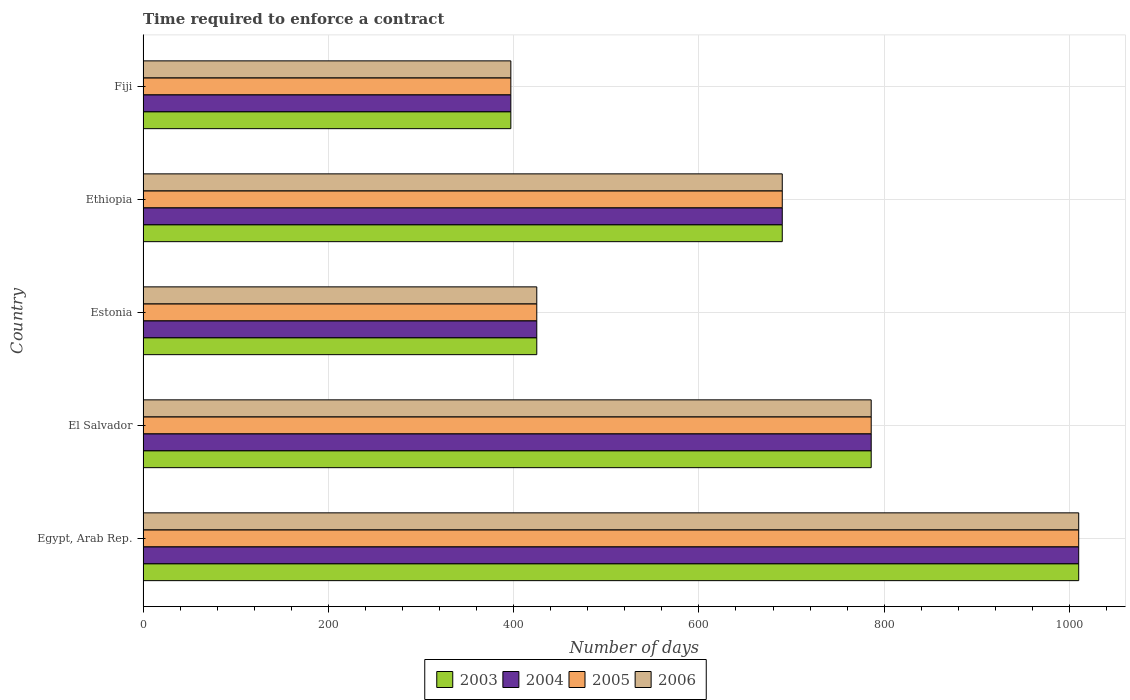How many groups of bars are there?
Provide a short and direct response. 5. Are the number of bars per tick equal to the number of legend labels?
Give a very brief answer. Yes. How many bars are there on the 3rd tick from the bottom?
Your response must be concise. 4. What is the label of the 5th group of bars from the top?
Ensure brevity in your answer.  Egypt, Arab Rep. What is the number of days required to enforce a contract in 2003 in Ethiopia?
Your answer should be compact. 690. Across all countries, what is the maximum number of days required to enforce a contract in 2005?
Keep it short and to the point. 1010. Across all countries, what is the minimum number of days required to enforce a contract in 2005?
Offer a terse response. 397. In which country was the number of days required to enforce a contract in 2004 maximum?
Provide a short and direct response. Egypt, Arab Rep. In which country was the number of days required to enforce a contract in 2006 minimum?
Ensure brevity in your answer.  Fiji. What is the total number of days required to enforce a contract in 2004 in the graph?
Make the answer very short. 3308. What is the difference between the number of days required to enforce a contract in 2006 in Egypt, Arab Rep. and that in Estonia?
Your response must be concise. 585. What is the difference between the number of days required to enforce a contract in 2003 in El Salvador and the number of days required to enforce a contract in 2005 in Ethiopia?
Your answer should be compact. 96. What is the average number of days required to enforce a contract in 2003 per country?
Ensure brevity in your answer.  661.6. What is the ratio of the number of days required to enforce a contract in 2003 in Egypt, Arab Rep. to that in Fiji?
Offer a very short reply. 2.54. Is the number of days required to enforce a contract in 2004 in Ethiopia less than that in Fiji?
Ensure brevity in your answer.  No. Is the difference between the number of days required to enforce a contract in 2004 in Egypt, Arab Rep. and Fiji greater than the difference between the number of days required to enforce a contract in 2003 in Egypt, Arab Rep. and Fiji?
Offer a very short reply. No. What is the difference between the highest and the second highest number of days required to enforce a contract in 2003?
Keep it short and to the point. 224. What is the difference between the highest and the lowest number of days required to enforce a contract in 2006?
Offer a terse response. 613. Is it the case that in every country, the sum of the number of days required to enforce a contract in 2004 and number of days required to enforce a contract in 2006 is greater than the sum of number of days required to enforce a contract in 2005 and number of days required to enforce a contract in 2003?
Your answer should be compact. No. What does the 1st bar from the bottom in El Salvador represents?
Make the answer very short. 2003. Where does the legend appear in the graph?
Make the answer very short. Bottom center. How many legend labels are there?
Give a very brief answer. 4. What is the title of the graph?
Keep it short and to the point. Time required to enforce a contract. What is the label or title of the X-axis?
Ensure brevity in your answer.  Number of days. What is the Number of days of 2003 in Egypt, Arab Rep.?
Your response must be concise. 1010. What is the Number of days in 2004 in Egypt, Arab Rep.?
Your response must be concise. 1010. What is the Number of days in 2005 in Egypt, Arab Rep.?
Your answer should be compact. 1010. What is the Number of days in 2006 in Egypt, Arab Rep.?
Ensure brevity in your answer.  1010. What is the Number of days in 2003 in El Salvador?
Your answer should be very brief. 786. What is the Number of days in 2004 in El Salvador?
Your answer should be compact. 786. What is the Number of days in 2005 in El Salvador?
Provide a short and direct response. 786. What is the Number of days in 2006 in El Salvador?
Provide a succinct answer. 786. What is the Number of days of 2003 in Estonia?
Keep it short and to the point. 425. What is the Number of days in 2004 in Estonia?
Your answer should be very brief. 425. What is the Number of days of 2005 in Estonia?
Your answer should be compact. 425. What is the Number of days of 2006 in Estonia?
Offer a very short reply. 425. What is the Number of days in 2003 in Ethiopia?
Your answer should be very brief. 690. What is the Number of days of 2004 in Ethiopia?
Offer a very short reply. 690. What is the Number of days in 2005 in Ethiopia?
Offer a very short reply. 690. What is the Number of days of 2006 in Ethiopia?
Offer a very short reply. 690. What is the Number of days of 2003 in Fiji?
Provide a succinct answer. 397. What is the Number of days of 2004 in Fiji?
Keep it short and to the point. 397. What is the Number of days in 2005 in Fiji?
Offer a terse response. 397. What is the Number of days of 2006 in Fiji?
Your answer should be very brief. 397. Across all countries, what is the maximum Number of days in 2003?
Your response must be concise. 1010. Across all countries, what is the maximum Number of days of 2004?
Offer a terse response. 1010. Across all countries, what is the maximum Number of days of 2005?
Your answer should be very brief. 1010. Across all countries, what is the maximum Number of days in 2006?
Your answer should be compact. 1010. Across all countries, what is the minimum Number of days of 2003?
Provide a short and direct response. 397. Across all countries, what is the minimum Number of days in 2004?
Give a very brief answer. 397. Across all countries, what is the minimum Number of days of 2005?
Provide a short and direct response. 397. Across all countries, what is the minimum Number of days of 2006?
Make the answer very short. 397. What is the total Number of days in 2003 in the graph?
Make the answer very short. 3308. What is the total Number of days of 2004 in the graph?
Offer a terse response. 3308. What is the total Number of days in 2005 in the graph?
Your answer should be very brief. 3308. What is the total Number of days in 2006 in the graph?
Give a very brief answer. 3308. What is the difference between the Number of days in 2003 in Egypt, Arab Rep. and that in El Salvador?
Ensure brevity in your answer.  224. What is the difference between the Number of days of 2004 in Egypt, Arab Rep. and that in El Salvador?
Your answer should be compact. 224. What is the difference between the Number of days of 2005 in Egypt, Arab Rep. and that in El Salvador?
Offer a terse response. 224. What is the difference between the Number of days of 2006 in Egypt, Arab Rep. and that in El Salvador?
Provide a short and direct response. 224. What is the difference between the Number of days in 2003 in Egypt, Arab Rep. and that in Estonia?
Provide a short and direct response. 585. What is the difference between the Number of days in 2004 in Egypt, Arab Rep. and that in Estonia?
Your answer should be compact. 585. What is the difference between the Number of days in 2005 in Egypt, Arab Rep. and that in Estonia?
Your answer should be compact. 585. What is the difference between the Number of days of 2006 in Egypt, Arab Rep. and that in Estonia?
Offer a very short reply. 585. What is the difference between the Number of days of 2003 in Egypt, Arab Rep. and that in Ethiopia?
Offer a terse response. 320. What is the difference between the Number of days in 2004 in Egypt, Arab Rep. and that in Ethiopia?
Make the answer very short. 320. What is the difference between the Number of days of 2005 in Egypt, Arab Rep. and that in Ethiopia?
Provide a succinct answer. 320. What is the difference between the Number of days of 2006 in Egypt, Arab Rep. and that in Ethiopia?
Ensure brevity in your answer.  320. What is the difference between the Number of days in 2003 in Egypt, Arab Rep. and that in Fiji?
Your answer should be compact. 613. What is the difference between the Number of days of 2004 in Egypt, Arab Rep. and that in Fiji?
Your answer should be very brief. 613. What is the difference between the Number of days of 2005 in Egypt, Arab Rep. and that in Fiji?
Your answer should be very brief. 613. What is the difference between the Number of days of 2006 in Egypt, Arab Rep. and that in Fiji?
Your answer should be compact. 613. What is the difference between the Number of days in 2003 in El Salvador and that in Estonia?
Keep it short and to the point. 361. What is the difference between the Number of days in 2004 in El Salvador and that in Estonia?
Your answer should be very brief. 361. What is the difference between the Number of days of 2005 in El Salvador and that in Estonia?
Your answer should be compact. 361. What is the difference between the Number of days in 2006 in El Salvador and that in Estonia?
Offer a very short reply. 361. What is the difference between the Number of days in 2003 in El Salvador and that in Ethiopia?
Your answer should be very brief. 96. What is the difference between the Number of days in 2004 in El Salvador and that in Ethiopia?
Offer a very short reply. 96. What is the difference between the Number of days in 2005 in El Salvador and that in Ethiopia?
Provide a succinct answer. 96. What is the difference between the Number of days of 2006 in El Salvador and that in Ethiopia?
Your answer should be very brief. 96. What is the difference between the Number of days of 2003 in El Salvador and that in Fiji?
Make the answer very short. 389. What is the difference between the Number of days in 2004 in El Salvador and that in Fiji?
Offer a very short reply. 389. What is the difference between the Number of days of 2005 in El Salvador and that in Fiji?
Your response must be concise. 389. What is the difference between the Number of days of 2006 in El Salvador and that in Fiji?
Make the answer very short. 389. What is the difference between the Number of days of 2003 in Estonia and that in Ethiopia?
Offer a very short reply. -265. What is the difference between the Number of days of 2004 in Estonia and that in Ethiopia?
Your answer should be compact. -265. What is the difference between the Number of days of 2005 in Estonia and that in Ethiopia?
Ensure brevity in your answer.  -265. What is the difference between the Number of days in 2006 in Estonia and that in Ethiopia?
Give a very brief answer. -265. What is the difference between the Number of days of 2004 in Estonia and that in Fiji?
Make the answer very short. 28. What is the difference between the Number of days of 2003 in Ethiopia and that in Fiji?
Offer a very short reply. 293. What is the difference between the Number of days in 2004 in Ethiopia and that in Fiji?
Ensure brevity in your answer.  293. What is the difference between the Number of days of 2005 in Ethiopia and that in Fiji?
Ensure brevity in your answer.  293. What is the difference between the Number of days in 2006 in Ethiopia and that in Fiji?
Give a very brief answer. 293. What is the difference between the Number of days in 2003 in Egypt, Arab Rep. and the Number of days in 2004 in El Salvador?
Make the answer very short. 224. What is the difference between the Number of days of 2003 in Egypt, Arab Rep. and the Number of days of 2005 in El Salvador?
Offer a very short reply. 224. What is the difference between the Number of days of 2003 in Egypt, Arab Rep. and the Number of days of 2006 in El Salvador?
Give a very brief answer. 224. What is the difference between the Number of days in 2004 in Egypt, Arab Rep. and the Number of days in 2005 in El Salvador?
Your answer should be compact. 224. What is the difference between the Number of days in 2004 in Egypt, Arab Rep. and the Number of days in 2006 in El Salvador?
Provide a short and direct response. 224. What is the difference between the Number of days of 2005 in Egypt, Arab Rep. and the Number of days of 2006 in El Salvador?
Provide a short and direct response. 224. What is the difference between the Number of days of 2003 in Egypt, Arab Rep. and the Number of days of 2004 in Estonia?
Provide a succinct answer. 585. What is the difference between the Number of days of 2003 in Egypt, Arab Rep. and the Number of days of 2005 in Estonia?
Offer a terse response. 585. What is the difference between the Number of days in 2003 in Egypt, Arab Rep. and the Number of days in 2006 in Estonia?
Provide a succinct answer. 585. What is the difference between the Number of days of 2004 in Egypt, Arab Rep. and the Number of days of 2005 in Estonia?
Your response must be concise. 585. What is the difference between the Number of days of 2004 in Egypt, Arab Rep. and the Number of days of 2006 in Estonia?
Your response must be concise. 585. What is the difference between the Number of days of 2005 in Egypt, Arab Rep. and the Number of days of 2006 in Estonia?
Offer a very short reply. 585. What is the difference between the Number of days of 2003 in Egypt, Arab Rep. and the Number of days of 2004 in Ethiopia?
Make the answer very short. 320. What is the difference between the Number of days in 2003 in Egypt, Arab Rep. and the Number of days in 2005 in Ethiopia?
Offer a very short reply. 320. What is the difference between the Number of days in 2003 in Egypt, Arab Rep. and the Number of days in 2006 in Ethiopia?
Your answer should be compact. 320. What is the difference between the Number of days of 2004 in Egypt, Arab Rep. and the Number of days of 2005 in Ethiopia?
Provide a succinct answer. 320. What is the difference between the Number of days in 2004 in Egypt, Arab Rep. and the Number of days in 2006 in Ethiopia?
Make the answer very short. 320. What is the difference between the Number of days in 2005 in Egypt, Arab Rep. and the Number of days in 2006 in Ethiopia?
Ensure brevity in your answer.  320. What is the difference between the Number of days in 2003 in Egypt, Arab Rep. and the Number of days in 2004 in Fiji?
Provide a short and direct response. 613. What is the difference between the Number of days in 2003 in Egypt, Arab Rep. and the Number of days in 2005 in Fiji?
Provide a short and direct response. 613. What is the difference between the Number of days of 2003 in Egypt, Arab Rep. and the Number of days of 2006 in Fiji?
Make the answer very short. 613. What is the difference between the Number of days of 2004 in Egypt, Arab Rep. and the Number of days of 2005 in Fiji?
Offer a terse response. 613. What is the difference between the Number of days in 2004 in Egypt, Arab Rep. and the Number of days in 2006 in Fiji?
Make the answer very short. 613. What is the difference between the Number of days of 2005 in Egypt, Arab Rep. and the Number of days of 2006 in Fiji?
Offer a terse response. 613. What is the difference between the Number of days of 2003 in El Salvador and the Number of days of 2004 in Estonia?
Your answer should be compact. 361. What is the difference between the Number of days in 2003 in El Salvador and the Number of days in 2005 in Estonia?
Give a very brief answer. 361. What is the difference between the Number of days of 2003 in El Salvador and the Number of days of 2006 in Estonia?
Provide a succinct answer. 361. What is the difference between the Number of days in 2004 in El Salvador and the Number of days in 2005 in Estonia?
Provide a short and direct response. 361. What is the difference between the Number of days in 2004 in El Salvador and the Number of days in 2006 in Estonia?
Keep it short and to the point. 361. What is the difference between the Number of days in 2005 in El Salvador and the Number of days in 2006 in Estonia?
Provide a succinct answer. 361. What is the difference between the Number of days of 2003 in El Salvador and the Number of days of 2004 in Ethiopia?
Provide a short and direct response. 96. What is the difference between the Number of days in 2003 in El Salvador and the Number of days in 2005 in Ethiopia?
Give a very brief answer. 96. What is the difference between the Number of days in 2003 in El Salvador and the Number of days in 2006 in Ethiopia?
Provide a succinct answer. 96. What is the difference between the Number of days in 2004 in El Salvador and the Number of days in 2005 in Ethiopia?
Keep it short and to the point. 96. What is the difference between the Number of days of 2004 in El Salvador and the Number of days of 2006 in Ethiopia?
Give a very brief answer. 96. What is the difference between the Number of days of 2005 in El Salvador and the Number of days of 2006 in Ethiopia?
Make the answer very short. 96. What is the difference between the Number of days of 2003 in El Salvador and the Number of days of 2004 in Fiji?
Offer a very short reply. 389. What is the difference between the Number of days in 2003 in El Salvador and the Number of days in 2005 in Fiji?
Your answer should be very brief. 389. What is the difference between the Number of days of 2003 in El Salvador and the Number of days of 2006 in Fiji?
Your answer should be very brief. 389. What is the difference between the Number of days in 2004 in El Salvador and the Number of days in 2005 in Fiji?
Ensure brevity in your answer.  389. What is the difference between the Number of days of 2004 in El Salvador and the Number of days of 2006 in Fiji?
Make the answer very short. 389. What is the difference between the Number of days of 2005 in El Salvador and the Number of days of 2006 in Fiji?
Provide a short and direct response. 389. What is the difference between the Number of days in 2003 in Estonia and the Number of days in 2004 in Ethiopia?
Offer a very short reply. -265. What is the difference between the Number of days of 2003 in Estonia and the Number of days of 2005 in Ethiopia?
Your answer should be compact. -265. What is the difference between the Number of days in 2003 in Estonia and the Number of days in 2006 in Ethiopia?
Your answer should be very brief. -265. What is the difference between the Number of days in 2004 in Estonia and the Number of days in 2005 in Ethiopia?
Your response must be concise. -265. What is the difference between the Number of days of 2004 in Estonia and the Number of days of 2006 in Ethiopia?
Your answer should be very brief. -265. What is the difference between the Number of days in 2005 in Estonia and the Number of days in 2006 in Ethiopia?
Offer a very short reply. -265. What is the difference between the Number of days in 2003 in Estonia and the Number of days in 2004 in Fiji?
Your response must be concise. 28. What is the difference between the Number of days in 2004 in Estonia and the Number of days in 2006 in Fiji?
Your answer should be very brief. 28. What is the difference between the Number of days of 2005 in Estonia and the Number of days of 2006 in Fiji?
Your answer should be compact. 28. What is the difference between the Number of days in 2003 in Ethiopia and the Number of days in 2004 in Fiji?
Ensure brevity in your answer.  293. What is the difference between the Number of days in 2003 in Ethiopia and the Number of days in 2005 in Fiji?
Your answer should be very brief. 293. What is the difference between the Number of days in 2003 in Ethiopia and the Number of days in 2006 in Fiji?
Ensure brevity in your answer.  293. What is the difference between the Number of days of 2004 in Ethiopia and the Number of days of 2005 in Fiji?
Give a very brief answer. 293. What is the difference between the Number of days in 2004 in Ethiopia and the Number of days in 2006 in Fiji?
Your answer should be very brief. 293. What is the difference between the Number of days of 2005 in Ethiopia and the Number of days of 2006 in Fiji?
Offer a very short reply. 293. What is the average Number of days in 2003 per country?
Offer a very short reply. 661.6. What is the average Number of days of 2004 per country?
Keep it short and to the point. 661.6. What is the average Number of days of 2005 per country?
Provide a succinct answer. 661.6. What is the average Number of days in 2006 per country?
Keep it short and to the point. 661.6. What is the difference between the Number of days of 2003 and Number of days of 2004 in Egypt, Arab Rep.?
Provide a short and direct response. 0. What is the difference between the Number of days in 2003 and Number of days in 2005 in Egypt, Arab Rep.?
Give a very brief answer. 0. What is the difference between the Number of days of 2003 and Number of days of 2006 in Egypt, Arab Rep.?
Keep it short and to the point. 0. What is the difference between the Number of days in 2004 and Number of days in 2005 in Egypt, Arab Rep.?
Provide a short and direct response. 0. What is the difference between the Number of days of 2003 and Number of days of 2005 in El Salvador?
Offer a very short reply. 0. What is the difference between the Number of days in 2003 and Number of days in 2006 in El Salvador?
Ensure brevity in your answer.  0. What is the difference between the Number of days of 2004 and Number of days of 2005 in El Salvador?
Offer a very short reply. 0. What is the difference between the Number of days in 2005 and Number of days in 2006 in El Salvador?
Provide a succinct answer. 0. What is the difference between the Number of days in 2003 and Number of days in 2004 in Estonia?
Make the answer very short. 0. What is the difference between the Number of days of 2004 and Number of days of 2005 in Estonia?
Offer a terse response. 0. What is the difference between the Number of days of 2004 and Number of days of 2006 in Estonia?
Your answer should be very brief. 0. What is the difference between the Number of days of 2005 and Number of days of 2006 in Estonia?
Your answer should be very brief. 0. What is the difference between the Number of days of 2003 and Number of days of 2004 in Ethiopia?
Keep it short and to the point. 0. What is the difference between the Number of days of 2005 and Number of days of 2006 in Ethiopia?
Offer a terse response. 0. What is the difference between the Number of days of 2003 and Number of days of 2004 in Fiji?
Give a very brief answer. 0. What is the difference between the Number of days of 2003 and Number of days of 2005 in Fiji?
Provide a short and direct response. 0. What is the difference between the Number of days of 2004 and Number of days of 2005 in Fiji?
Ensure brevity in your answer.  0. What is the difference between the Number of days in 2004 and Number of days in 2006 in Fiji?
Your answer should be very brief. 0. What is the ratio of the Number of days of 2003 in Egypt, Arab Rep. to that in El Salvador?
Make the answer very short. 1.28. What is the ratio of the Number of days in 2004 in Egypt, Arab Rep. to that in El Salvador?
Provide a succinct answer. 1.28. What is the ratio of the Number of days of 2005 in Egypt, Arab Rep. to that in El Salvador?
Keep it short and to the point. 1.28. What is the ratio of the Number of days of 2006 in Egypt, Arab Rep. to that in El Salvador?
Offer a very short reply. 1.28. What is the ratio of the Number of days of 2003 in Egypt, Arab Rep. to that in Estonia?
Make the answer very short. 2.38. What is the ratio of the Number of days of 2004 in Egypt, Arab Rep. to that in Estonia?
Provide a succinct answer. 2.38. What is the ratio of the Number of days in 2005 in Egypt, Arab Rep. to that in Estonia?
Offer a very short reply. 2.38. What is the ratio of the Number of days in 2006 in Egypt, Arab Rep. to that in Estonia?
Give a very brief answer. 2.38. What is the ratio of the Number of days of 2003 in Egypt, Arab Rep. to that in Ethiopia?
Your response must be concise. 1.46. What is the ratio of the Number of days in 2004 in Egypt, Arab Rep. to that in Ethiopia?
Provide a succinct answer. 1.46. What is the ratio of the Number of days in 2005 in Egypt, Arab Rep. to that in Ethiopia?
Ensure brevity in your answer.  1.46. What is the ratio of the Number of days in 2006 in Egypt, Arab Rep. to that in Ethiopia?
Ensure brevity in your answer.  1.46. What is the ratio of the Number of days in 2003 in Egypt, Arab Rep. to that in Fiji?
Offer a terse response. 2.54. What is the ratio of the Number of days of 2004 in Egypt, Arab Rep. to that in Fiji?
Ensure brevity in your answer.  2.54. What is the ratio of the Number of days in 2005 in Egypt, Arab Rep. to that in Fiji?
Keep it short and to the point. 2.54. What is the ratio of the Number of days in 2006 in Egypt, Arab Rep. to that in Fiji?
Give a very brief answer. 2.54. What is the ratio of the Number of days in 2003 in El Salvador to that in Estonia?
Provide a short and direct response. 1.85. What is the ratio of the Number of days of 2004 in El Salvador to that in Estonia?
Keep it short and to the point. 1.85. What is the ratio of the Number of days in 2005 in El Salvador to that in Estonia?
Your answer should be compact. 1.85. What is the ratio of the Number of days in 2006 in El Salvador to that in Estonia?
Your answer should be compact. 1.85. What is the ratio of the Number of days of 2003 in El Salvador to that in Ethiopia?
Your answer should be compact. 1.14. What is the ratio of the Number of days in 2004 in El Salvador to that in Ethiopia?
Keep it short and to the point. 1.14. What is the ratio of the Number of days in 2005 in El Salvador to that in Ethiopia?
Keep it short and to the point. 1.14. What is the ratio of the Number of days of 2006 in El Salvador to that in Ethiopia?
Keep it short and to the point. 1.14. What is the ratio of the Number of days in 2003 in El Salvador to that in Fiji?
Your answer should be very brief. 1.98. What is the ratio of the Number of days of 2004 in El Salvador to that in Fiji?
Offer a very short reply. 1.98. What is the ratio of the Number of days in 2005 in El Salvador to that in Fiji?
Offer a terse response. 1.98. What is the ratio of the Number of days of 2006 in El Salvador to that in Fiji?
Provide a short and direct response. 1.98. What is the ratio of the Number of days of 2003 in Estonia to that in Ethiopia?
Ensure brevity in your answer.  0.62. What is the ratio of the Number of days in 2004 in Estonia to that in Ethiopia?
Your answer should be compact. 0.62. What is the ratio of the Number of days in 2005 in Estonia to that in Ethiopia?
Make the answer very short. 0.62. What is the ratio of the Number of days of 2006 in Estonia to that in Ethiopia?
Provide a short and direct response. 0.62. What is the ratio of the Number of days of 2003 in Estonia to that in Fiji?
Make the answer very short. 1.07. What is the ratio of the Number of days of 2004 in Estonia to that in Fiji?
Your answer should be compact. 1.07. What is the ratio of the Number of days of 2005 in Estonia to that in Fiji?
Ensure brevity in your answer.  1.07. What is the ratio of the Number of days of 2006 in Estonia to that in Fiji?
Offer a terse response. 1.07. What is the ratio of the Number of days of 2003 in Ethiopia to that in Fiji?
Give a very brief answer. 1.74. What is the ratio of the Number of days in 2004 in Ethiopia to that in Fiji?
Ensure brevity in your answer.  1.74. What is the ratio of the Number of days of 2005 in Ethiopia to that in Fiji?
Keep it short and to the point. 1.74. What is the ratio of the Number of days of 2006 in Ethiopia to that in Fiji?
Make the answer very short. 1.74. What is the difference between the highest and the second highest Number of days of 2003?
Give a very brief answer. 224. What is the difference between the highest and the second highest Number of days of 2004?
Keep it short and to the point. 224. What is the difference between the highest and the second highest Number of days in 2005?
Offer a terse response. 224. What is the difference between the highest and the second highest Number of days of 2006?
Keep it short and to the point. 224. What is the difference between the highest and the lowest Number of days of 2003?
Make the answer very short. 613. What is the difference between the highest and the lowest Number of days in 2004?
Ensure brevity in your answer.  613. What is the difference between the highest and the lowest Number of days of 2005?
Your response must be concise. 613. What is the difference between the highest and the lowest Number of days of 2006?
Offer a very short reply. 613. 